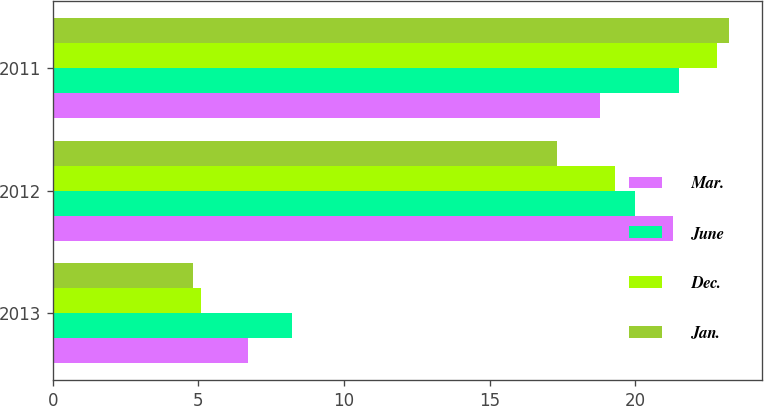Convert chart. <chart><loc_0><loc_0><loc_500><loc_500><stacked_bar_chart><ecel><fcel>2013<fcel>2012<fcel>2011<nl><fcel>Mar.<fcel>6.7<fcel>21.3<fcel>18.8<nl><fcel>June<fcel>8.2<fcel>20<fcel>21.5<nl><fcel>Dec.<fcel>5.1<fcel>19.3<fcel>22.8<nl><fcel>Jan.<fcel>4.8<fcel>17.3<fcel>23.2<nl></chart> 